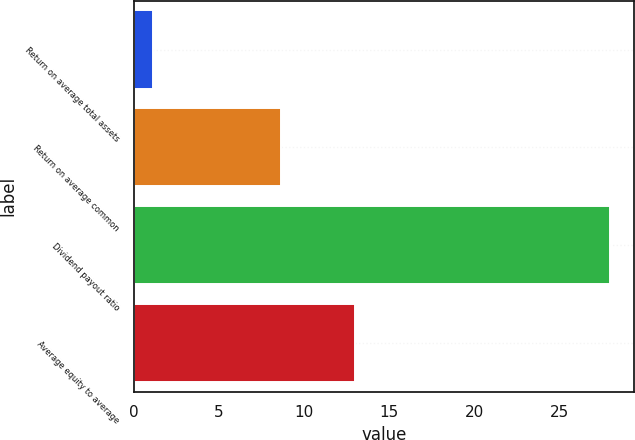Convert chart to OTSL. <chart><loc_0><loc_0><loc_500><loc_500><bar_chart><fcel>Return on average total assets<fcel>Return on average common<fcel>Dividend payout ratio<fcel>Average equity to average<nl><fcel>1.11<fcel>8.62<fcel>28<fcel>13.02<nl></chart> 